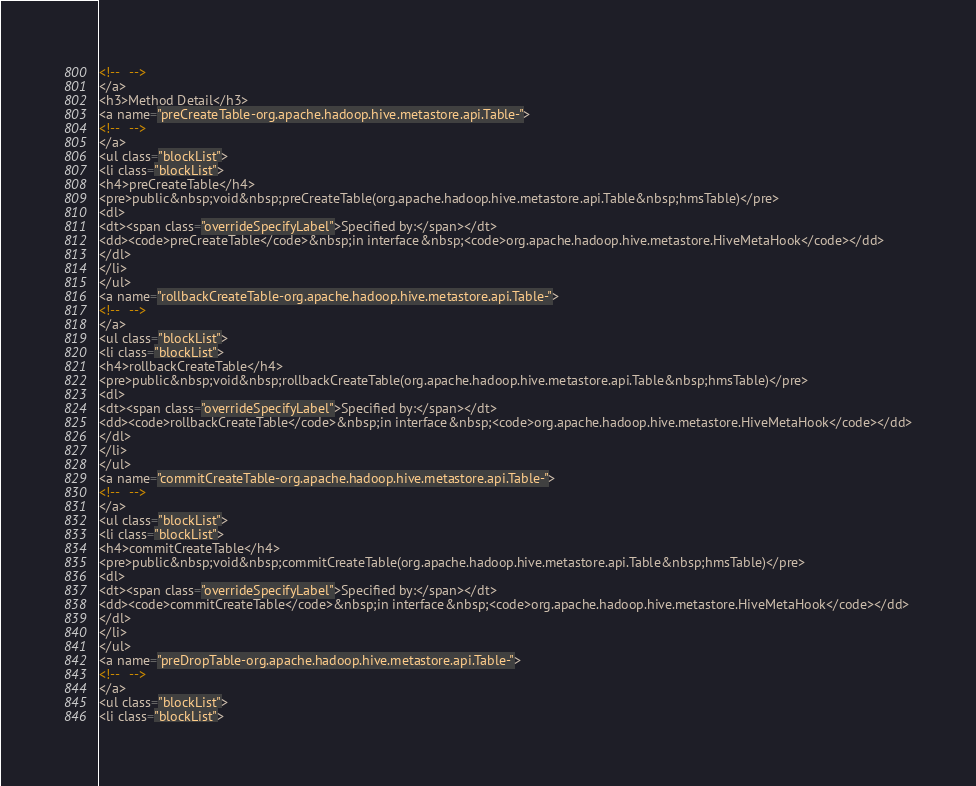Convert code to text. <code><loc_0><loc_0><loc_500><loc_500><_HTML_><!--   -->
</a>
<h3>Method Detail</h3>
<a name="preCreateTable-org.apache.hadoop.hive.metastore.api.Table-">
<!--   -->
</a>
<ul class="blockList">
<li class="blockList">
<h4>preCreateTable</h4>
<pre>public&nbsp;void&nbsp;preCreateTable(org.apache.hadoop.hive.metastore.api.Table&nbsp;hmsTable)</pre>
<dl>
<dt><span class="overrideSpecifyLabel">Specified by:</span></dt>
<dd><code>preCreateTable</code>&nbsp;in interface&nbsp;<code>org.apache.hadoop.hive.metastore.HiveMetaHook</code></dd>
</dl>
</li>
</ul>
<a name="rollbackCreateTable-org.apache.hadoop.hive.metastore.api.Table-">
<!--   -->
</a>
<ul class="blockList">
<li class="blockList">
<h4>rollbackCreateTable</h4>
<pre>public&nbsp;void&nbsp;rollbackCreateTable(org.apache.hadoop.hive.metastore.api.Table&nbsp;hmsTable)</pre>
<dl>
<dt><span class="overrideSpecifyLabel">Specified by:</span></dt>
<dd><code>rollbackCreateTable</code>&nbsp;in interface&nbsp;<code>org.apache.hadoop.hive.metastore.HiveMetaHook</code></dd>
</dl>
</li>
</ul>
<a name="commitCreateTable-org.apache.hadoop.hive.metastore.api.Table-">
<!--   -->
</a>
<ul class="blockList">
<li class="blockList">
<h4>commitCreateTable</h4>
<pre>public&nbsp;void&nbsp;commitCreateTable(org.apache.hadoop.hive.metastore.api.Table&nbsp;hmsTable)</pre>
<dl>
<dt><span class="overrideSpecifyLabel">Specified by:</span></dt>
<dd><code>commitCreateTable</code>&nbsp;in interface&nbsp;<code>org.apache.hadoop.hive.metastore.HiveMetaHook</code></dd>
</dl>
</li>
</ul>
<a name="preDropTable-org.apache.hadoop.hive.metastore.api.Table-">
<!--   -->
</a>
<ul class="blockList">
<li class="blockList"></code> 